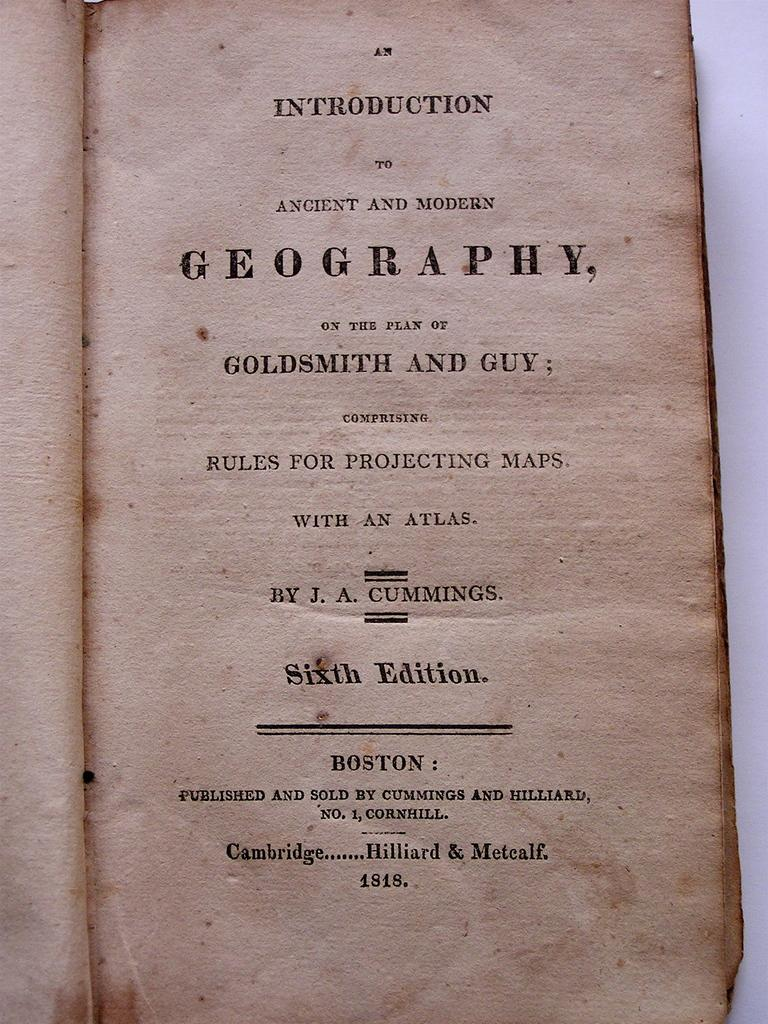<image>
Describe the image concisely. The opening page of an old book titled Ancient and Modern Geography. 